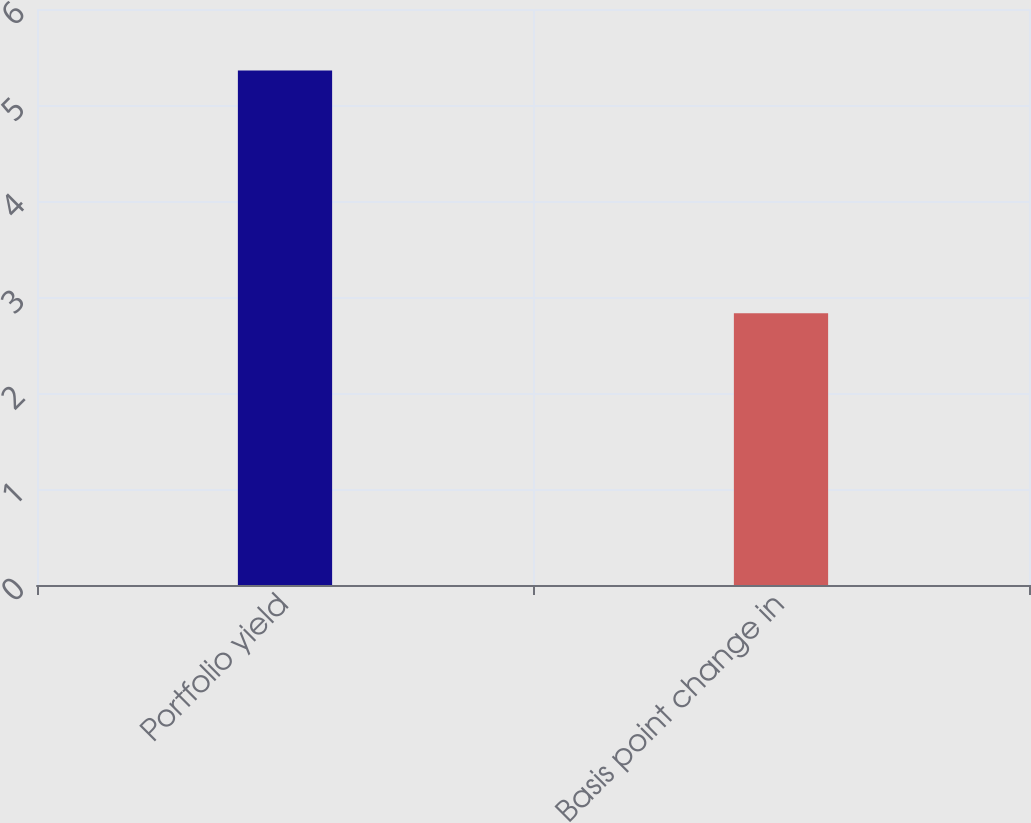<chart> <loc_0><loc_0><loc_500><loc_500><bar_chart><fcel>Portfolio yield<fcel>Basis point change in<nl><fcel>5.36<fcel>2.83<nl></chart> 